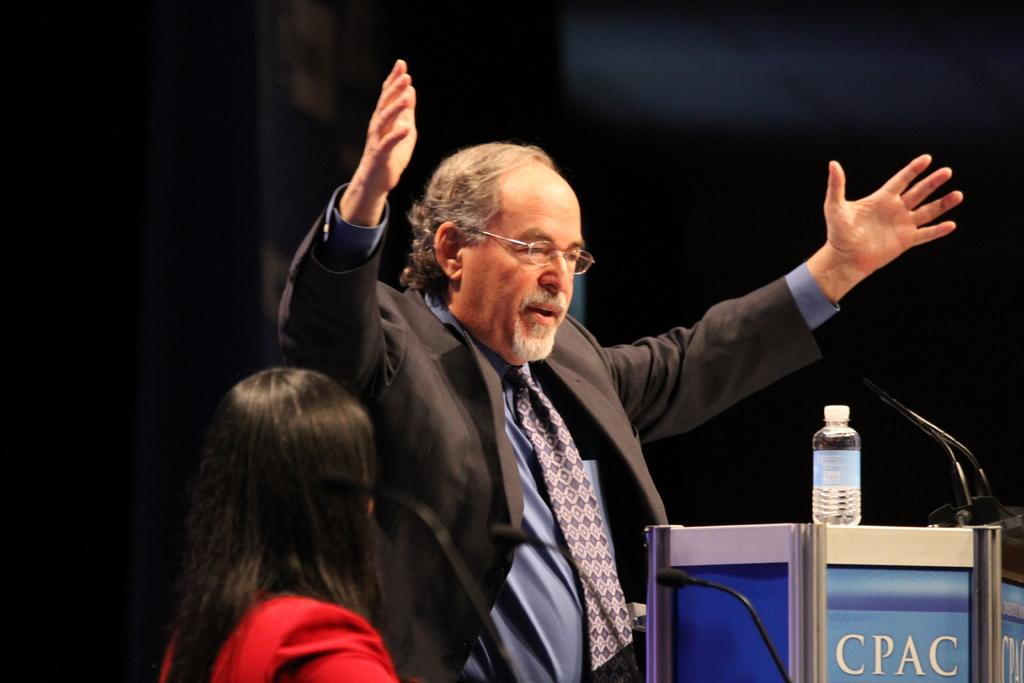<image>
Share a concise interpretation of the image provided. Man speaking in front of a podium that says "CPAC". 